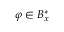Convert formula to latex. <formula><loc_0><loc_0><loc_500><loc_500>\varphi \in B _ { x } ^ { * }</formula> 